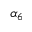Convert formula to latex. <formula><loc_0><loc_0><loc_500><loc_500>\alpha _ { 6 }</formula> 